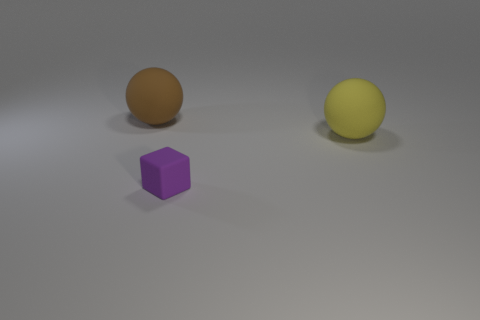Add 1 tiny purple things. How many objects exist? 4 Subtract all spheres. How many objects are left? 1 Subtract all matte objects. Subtract all small purple rubber spheres. How many objects are left? 0 Add 2 brown matte spheres. How many brown matte spheres are left? 3 Add 2 red matte cylinders. How many red matte cylinders exist? 2 Subtract 0 purple balls. How many objects are left? 3 